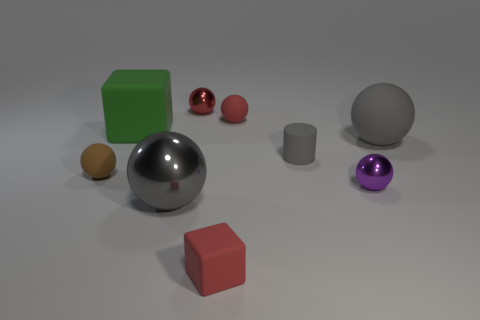Subtract all cylinders. How many objects are left? 8 Add 1 large red things. How many objects exist? 10 Subtract all small metal spheres. How many spheres are left? 4 Subtract all green rubber balls. Subtract all cylinders. How many objects are left? 8 Add 5 large gray metal spheres. How many large gray metal spheres are left? 6 Add 9 big yellow rubber objects. How many big yellow rubber objects exist? 9 Subtract all red cubes. How many cubes are left? 1 Subtract 1 purple balls. How many objects are left? 8 Subtract 2 balls. How many balls are left? 4 Subtract all purple cubes. Subtract all cyan cylinders. How many cubes are left? 2 